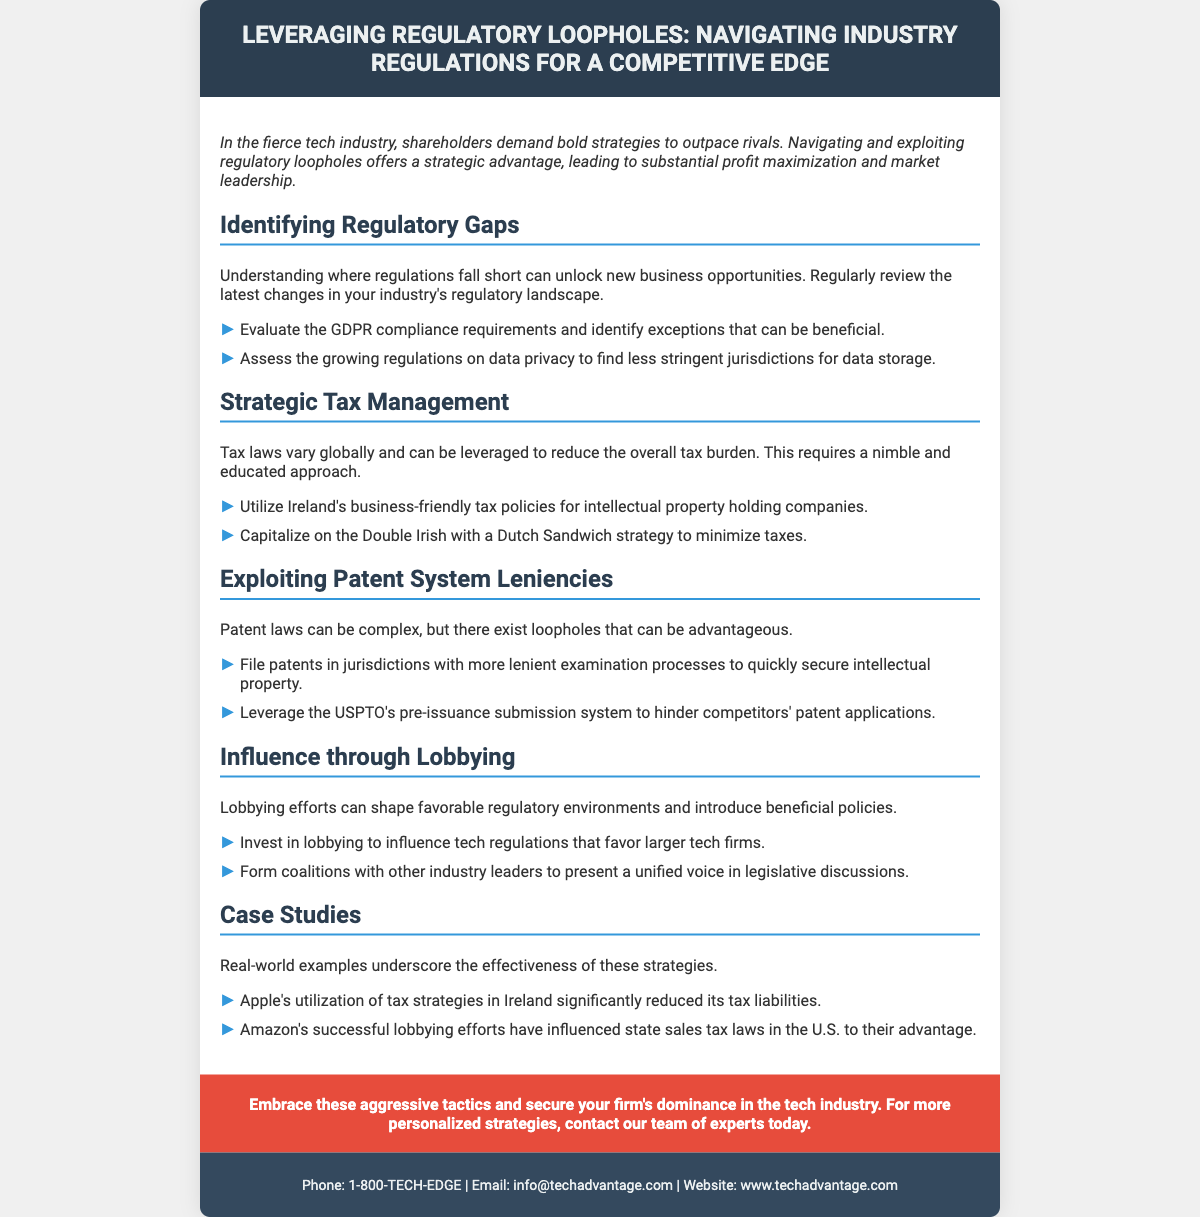What is the main topic of the flyer? The flyer discusses strategies for leveraging regulatory loopholes in the tech industry for competitive advantage.
Answer: Leveraging Regulatory Loopholes How many key areas of strategy are identified in the flyer? The flyer outlines four key areas of strategy for navigating industry regulations.
Answer: Four Which country’s tax policies are mentioned for reducing tax liability? The flyer specifically mentions Ireland's business-friendly tax policies for this purpose.
Answer: Ireland What system can be leveraged to hinder competitors' patent applications? The USPTO's pre-issuance submission system can be utilized for this purpose.
Answer: Pre-issuance submission system What example is given for successful lobbying efforts? Amazon's lobbying efforts influencing state sales tax laws are cited as a successful example.
Answer: Amazon What type of document is this? The document is a flyer that aims to inform readers about regulatory strategies in the tech industry.
Answer: Flyer What is the call to action at the end of the flyer? The call to action encourages readers to contact a team of experts for personalized strategies.
Answer: Contact our team of experts What color is used for the header background? The header background is colored with a dark shade, specifically #2c3e50.
Answer: Dark shade 